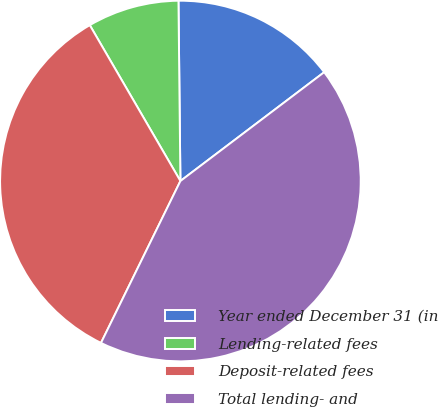<chart> <loc_0><loc_0><loc_500><loc_500><pie_chart><fcel>Year ended December 31 (in<fcel>Lending-related fees<fcel>Deposit-related fees<fcel>Total lending- and<nl><fcel>14.86%<fcel>8.21%<fcel>34.36%<fcel>42.57%<nl></chart> 